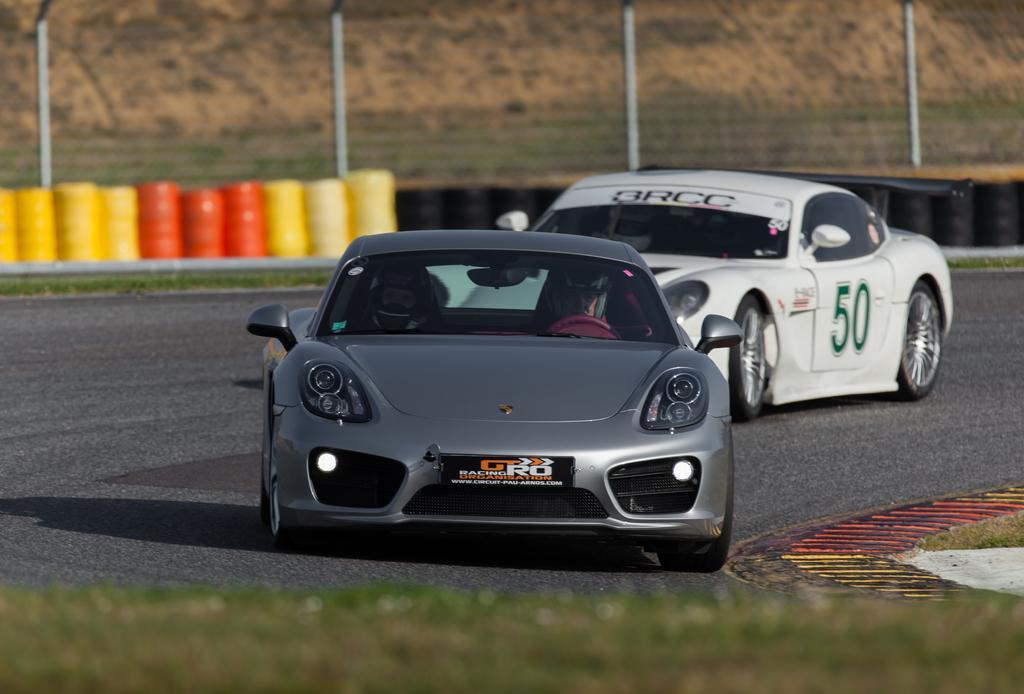In one or two sentences, can you explain what this image depicts? In this image there are two cars, there are persons in the car, there is the road, there are objects truncated towards the left of the image, there are tyres, truncated towards the right of the image, there is a fencing truncated towards the top of the image, there is grass truncated towards the bottom of the image. 